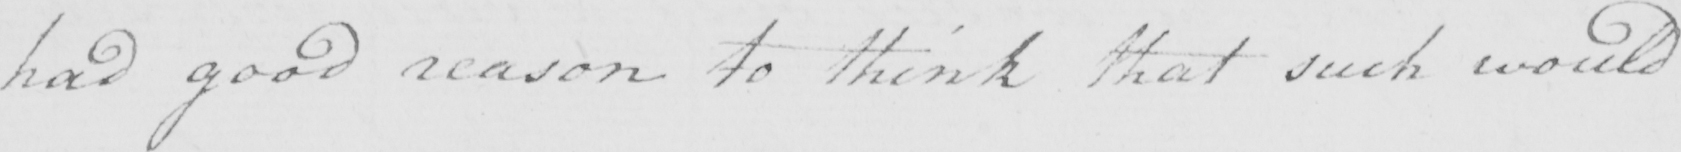Please transcribe the handwritten text in this image. had good reason to think that such would 